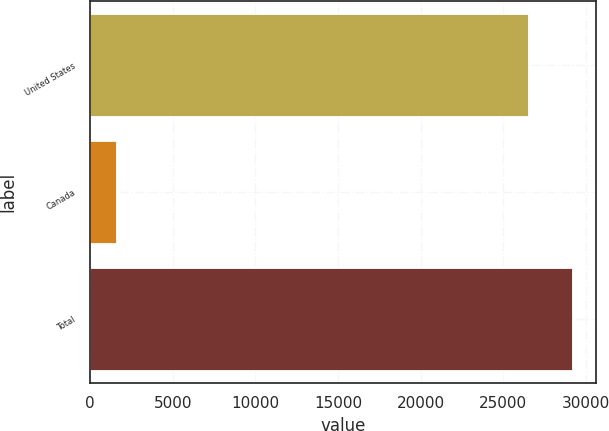Convert chart. <chart><loc_0><loc_0><loc_500><loc_500><bar_chart><fcel>United States<fcel>Canada<fcel>Total<nl><fcel>26500<fcel>1533<fcel>29150<nl></chart> 